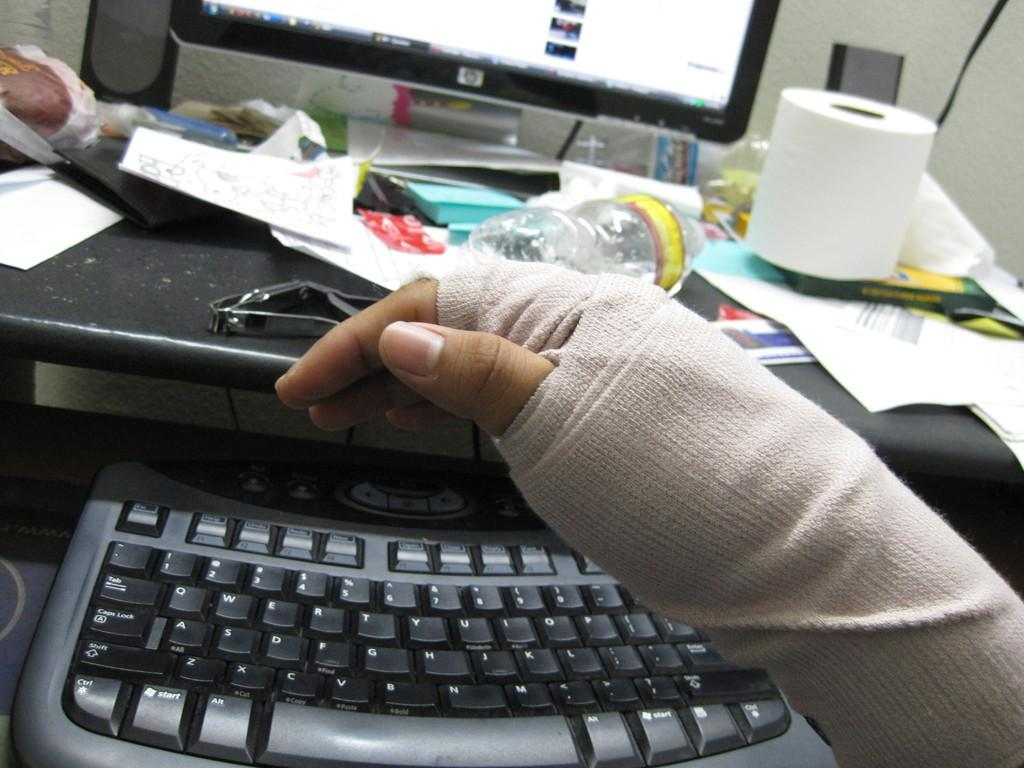<image>
Relay a brief, clear account of the picture shown. A bandaged hand hovering over a curved keyboard, with the TAB key on the top left 